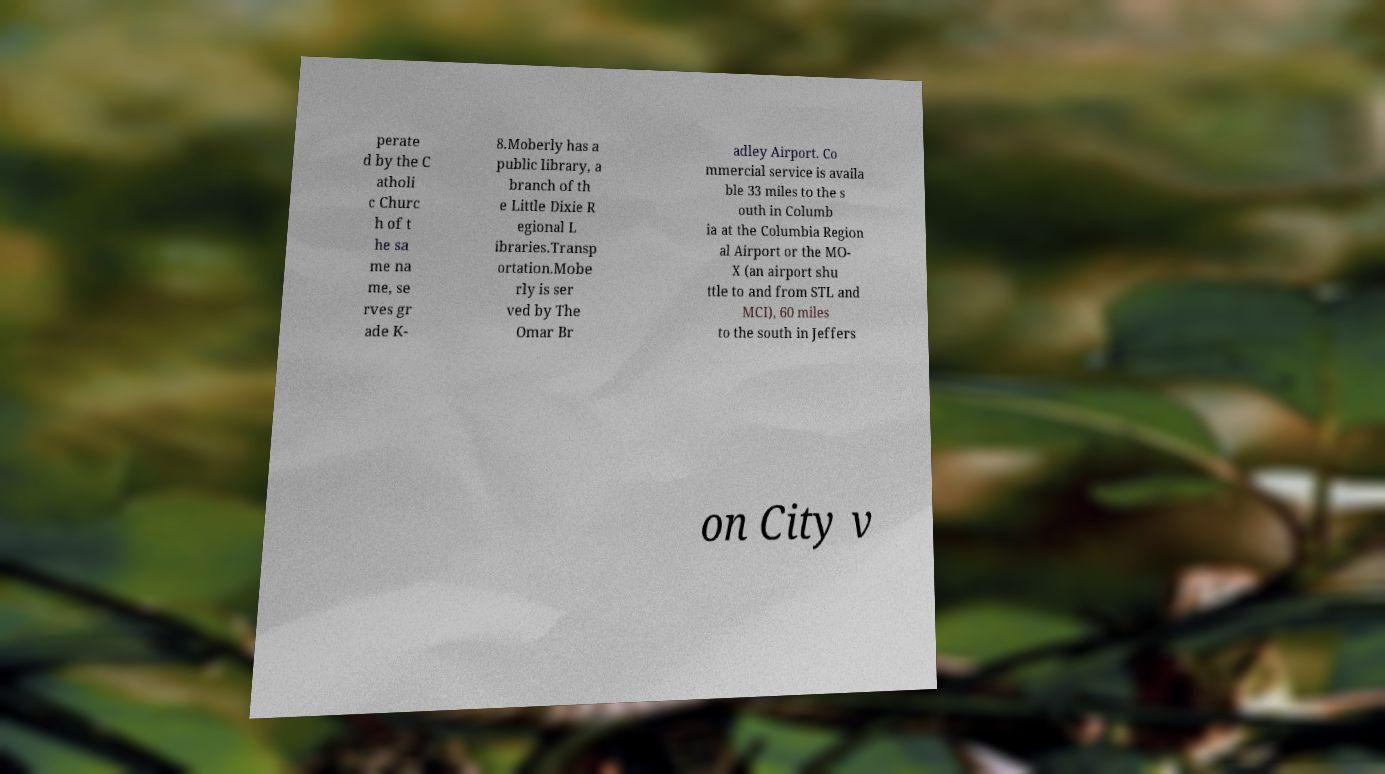Please read and relay the text visible in this image. What does it say? perate d by the C atholi c Churc h of t he sa me na me, se rves gr ade K- 8.Moberly has a public library, a branch of th e Little Dixie R egional L ibraries.Transp ortation.Mobe rly is ser ved by The Omar Br adley Airport. Co mmercial service is availa ble 33 miles to the s outh in Columb ia at the Columbia Region al Airport or the MO- X (an airport shu ttle to and from STL and MCI), 60 miles to the south in Jeffers on City v 